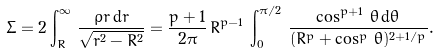<formula> <loc_0><loc_0><loc_500><loc_500>\Sigma = 2 \int _ { R } ^ { \infty } \, \frac { \rho r \, \mathrm d r } { \sqrt { r ^ { 2 } - R ^ { 2 } } } = \frac { p + 1 } { 2 \pi } \, R ^ { p - 1 } \, \int _ { 0 } ^ { \pi / 2 } \, \frac { \cos ^ { p + 1 } \, \theta \, \mathrm d \theta } { ( R ^ { p } + \cos ^ { p } \, \theta ) ^ { 2 + 1 / p } } .</formula> 